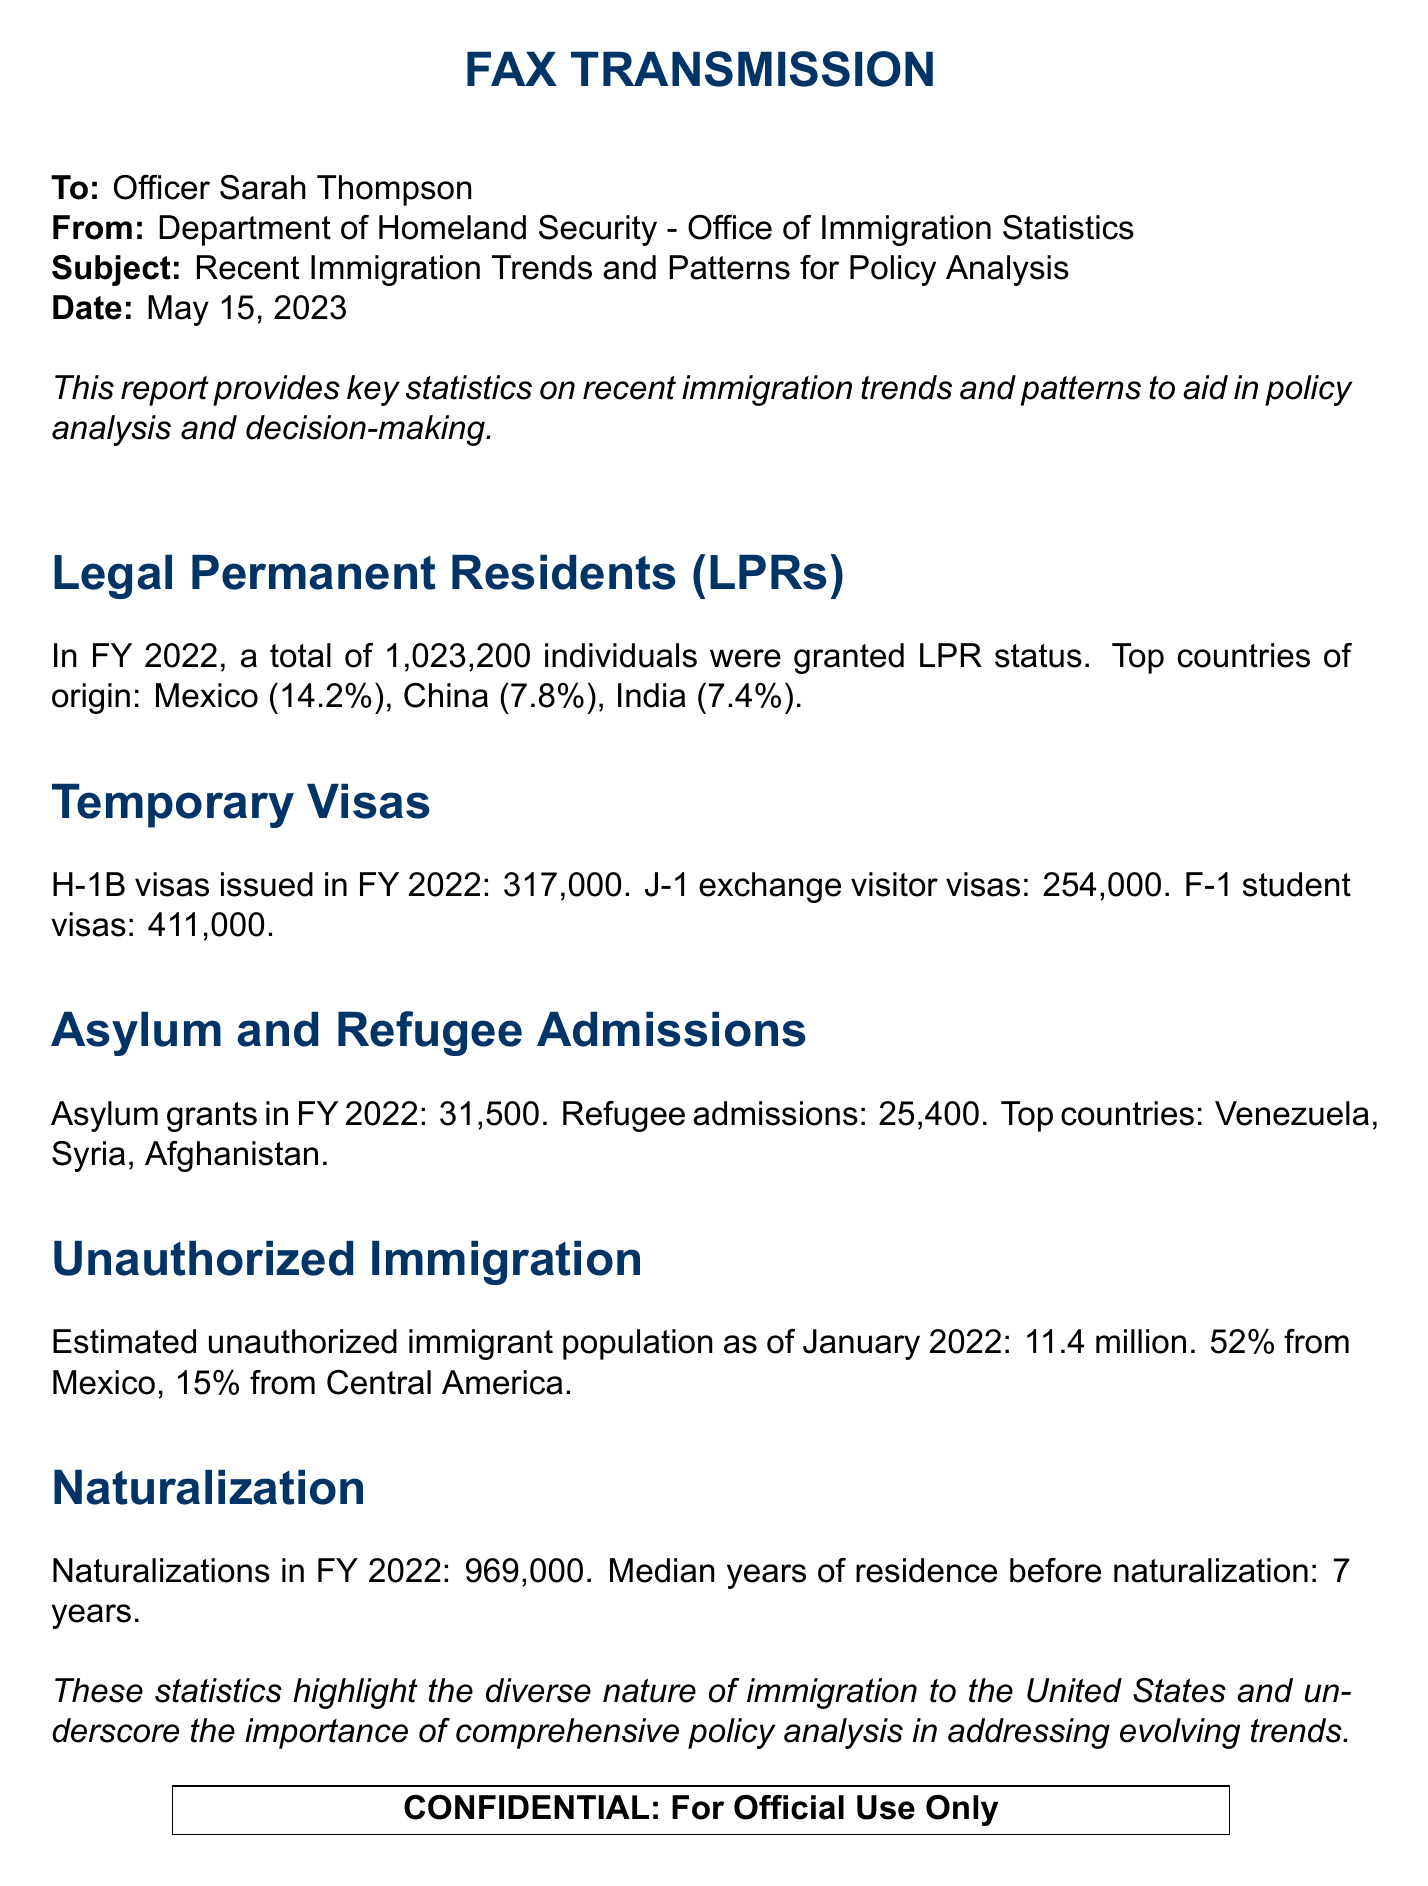What was the total number of individuals granted LPR status in FY 2022? The total number of individuals granted LPR status in the document is explicitly stated as 1,023,200.
Answer: 1,023,200 What percentage of LPRs in FY 2022 were from Mexico? The document specifies that 14.2% of the individuals granted LPR status were from Mexico.
Answer: 14.2% How many H-1B visas were issued in FY 2022? The document contains the specific number of H-1B visas issued, which is 317,000.
Answer: 317,000 What is the estimated unauthorized immigrant population as of January 2022? The document presents the estimated unauthorized immigrant population as 11.4 million.
Answer: 11.4 million Which country had the highest number of asylum grants in FY 2022? The document indicates that Venezuela is among the top countries for asylum grants in FY 2022.
Answer: Venezuela How many naturalizations occurred in FY 2022? The total number of naturalizations mentioned in the document for FY 2022 is 969,000.
Answer: 969,000 What does the report emphasize about immigration to the United States? The report highlights the diverse nature of immigration and the importance of comprehensive policy analysis.
Answer: Diversity and comprehensive policy analysis What is the median number of years of residence before naturalization? The document states that the median years of residence before naturalization is 7 years.
Answer: 7 years What type of data does this fax report provide? The fax report provides key statistics on immigration trends and patterns.
Answer: Key statistics on immigration trends 